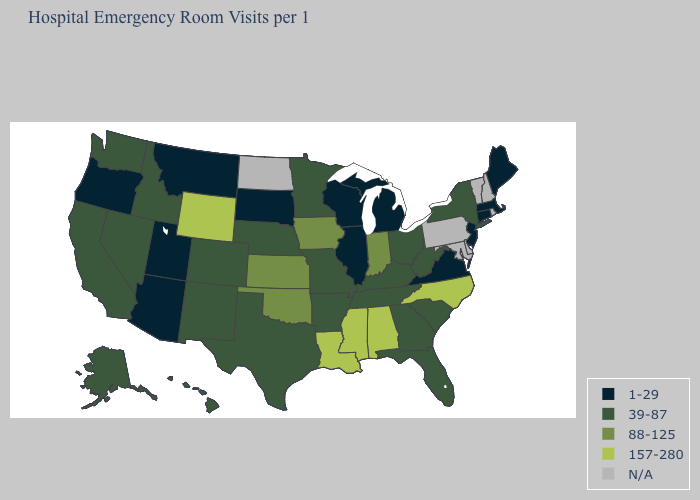What is the value of Louisiana?
Answer briefly. 157-280. What is the highest value in states that border Connecticut?
Concise answer only. 39-87. What is the value of Nevada?
Be succinct. 39-87. Name the states that have a value in the range 1-29?
Keep it brief. Arizona, Connecticut, Illinois, Maine, Massachusetts, Michigan, Montana, New Jersey, Oregon, South Dakota, Utah, Virginia, Wisconsin. What is the lowest value in the USA?
Answer briefly. 1-29. Name the states that have a value in the range 157-280?
Concise answer only. Alabama, Louisiana, Mississippi, North Carolina, Wyoming. Name the states that have a value in the range 157-280?
Short answer required. Alabama, Louisiana, Mississippi, North Carolina, Wyoming. Does Wyoming have the highest value in the USA?
Write a very short answer. Yes. Name the states that have a value in the range 88-125?
Give a very brief answer. Indiana, Iowa, Kansas, Oklahoma. Name the states that have a value in the range 39-87?
Be succinct. Alaska, Arkansas, California, Colorado, Florida, Georgia, Hawaii, Idaho, Kentucky, Minnesota, Missouri, Nebraska, Nevada, New Mexico, New York, Ohio, South Carolina, Tennessee, Texas, Washington, West Virginia. Which states have the highest value in the USA?
Concise answer only. Alabama, Louisiana, Mississippi, North Carolina, Wyoming. Does Colorado have the highest value in the USA?
Concise answer only. No. What is the value of Florida?
Answer briefly. 39-87. Is the legend a continuous bar?
Write a very short answer. No. Name the states that have a value in the range 1-29?
Write a very short answer. Arizona, Connecticut, Illinois, Maine, Massachusetts, Michigan, Montana, New Jersey, Oregon, South Dakota, Utah, Virginia, Wisconsin. 